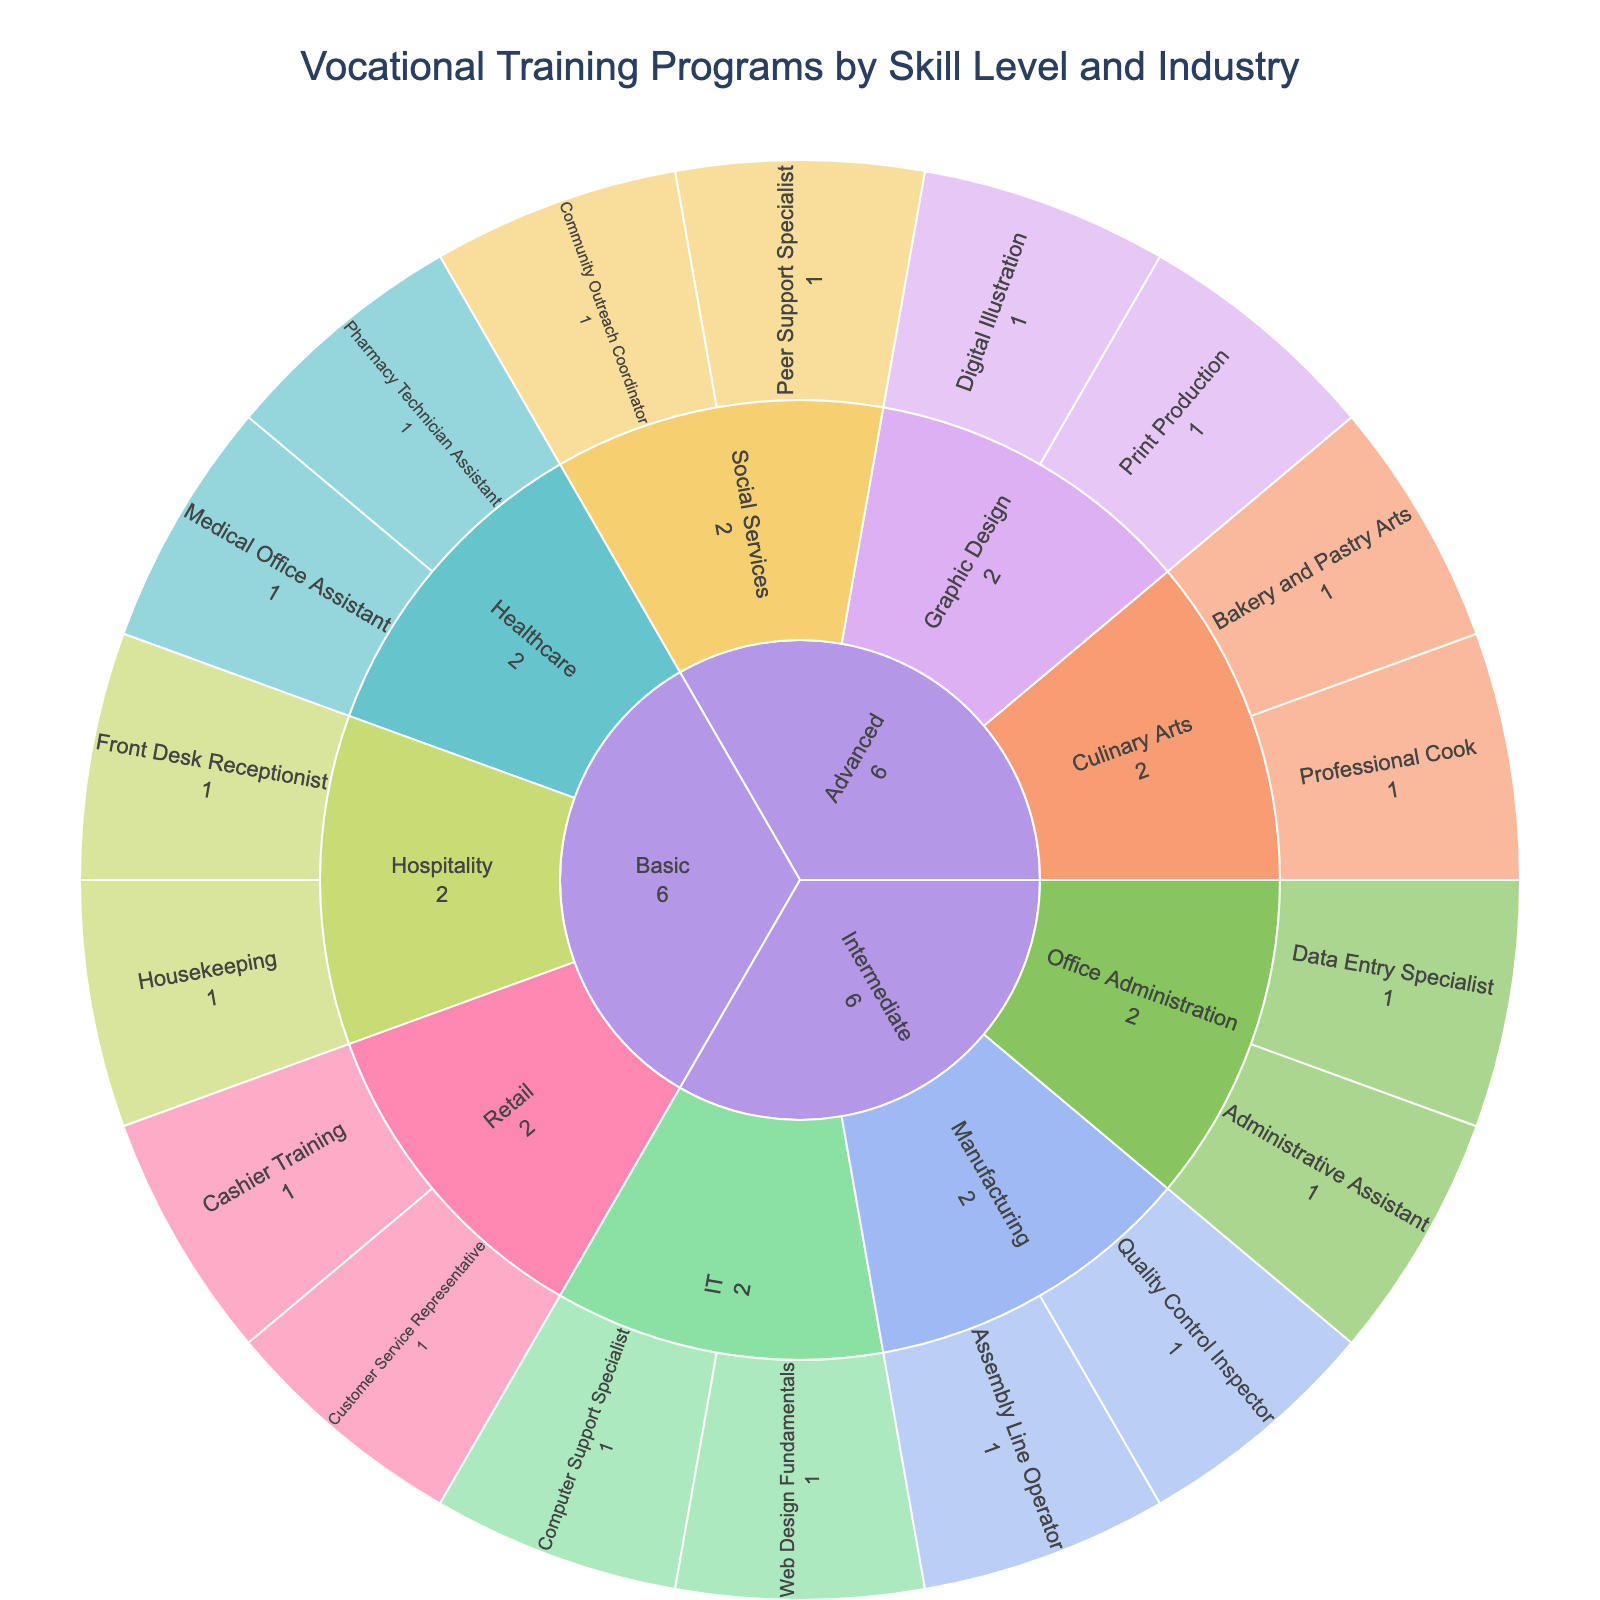What is the title of the Sunburst Plot? The title of the plot is typically positioned above the plot area. Based on the code provided, we can see the title update function is setting a custom title text.
Answer: Vocational Training Programs by Skill Level and Industry How many basic-level programs are there in the Healthcare industry? The sectors of the Sunburst plot corresponding to 'Basic' and 'Healthcare' need to be examined to count the number of programs.
Answer: 2 Which industry at the advanced skill level offers more programs: Culinary Arts or Graphic Design? For the 'Advanced' skill level, examine the sectors representing 'Culinary Arts' and 'Graphic Design', then count the programs within each sector.
Answer: Culinary Arts How many total programs are offered at the intermediate skill level across all industries? Look at all intermediate-level segments in the plot and count the total number of programs across all industries.
Answer: 6 Are there more basic-level programs in Hospitality or Retail? Compare the number of sectors under 'Basic' for both 'Hospitality' and 'Retail' to determine which has more programs.
Answer: Retail What is the total number of programs offered by the organization? Count all the programs across all skill levels and industries by summing up the innermost segments of the sunburst plot.
Answer: 18 How many industries are represented in the plot? Observe the second-tier segments of the plot, which represent industries branching out from skill levels. Each unique segment is a different industry.
Answer: 8 Which skill level offers the program "Web Design Fundamentals"? Locate the specific program 'Web Design Fundamentals' within the sunburst plot and identify the skill level category it falls under.
Answer: Intermediate How many different programs are offered in the IT industry? Identify the IT industry sectors across all skill levels and count the distinct programs listed in this industry.
Answer: 2 What are the two programs offered in the advanced level of Social Services? Examine the segments under the 'Advanced' skill level, then look at the specific programs listed within the 'Social Services' industry.
Answer: Peer Support Specialist, Community Outreach Coordinator 